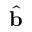<formula> <loc_0><loc_0><loc_500><loc_500>\hat { b }</formula> 